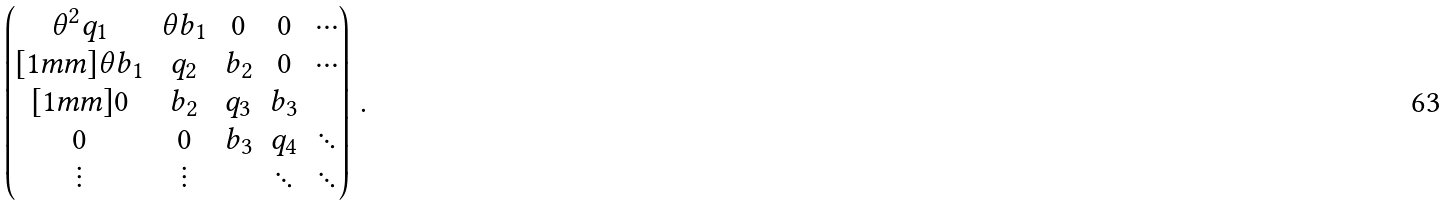Convert formula to latex. <formula><loc_0><loc_0><loc_500><loc_500>\begin{pmatrix} \theta ^ { 2 } q _ { 1 } & \theta b _ { 1 } & 0 & 0 & \cdots \\ [ 1 m m ] \theta b _ { 1 } & q _ { 2 } & b _ { 2 } & 0 & \cdots \\ [ 1 m m ] 0 & b _ { 2 } & q _ { 3 } & b _ { 3 } & \\ 0 & 0 & b _ { 3 } & q _ { 4 } & \ddots \\ \vdots & \vdots & & \ddots & \ddots \end{pmatrix} \, .</formula> 